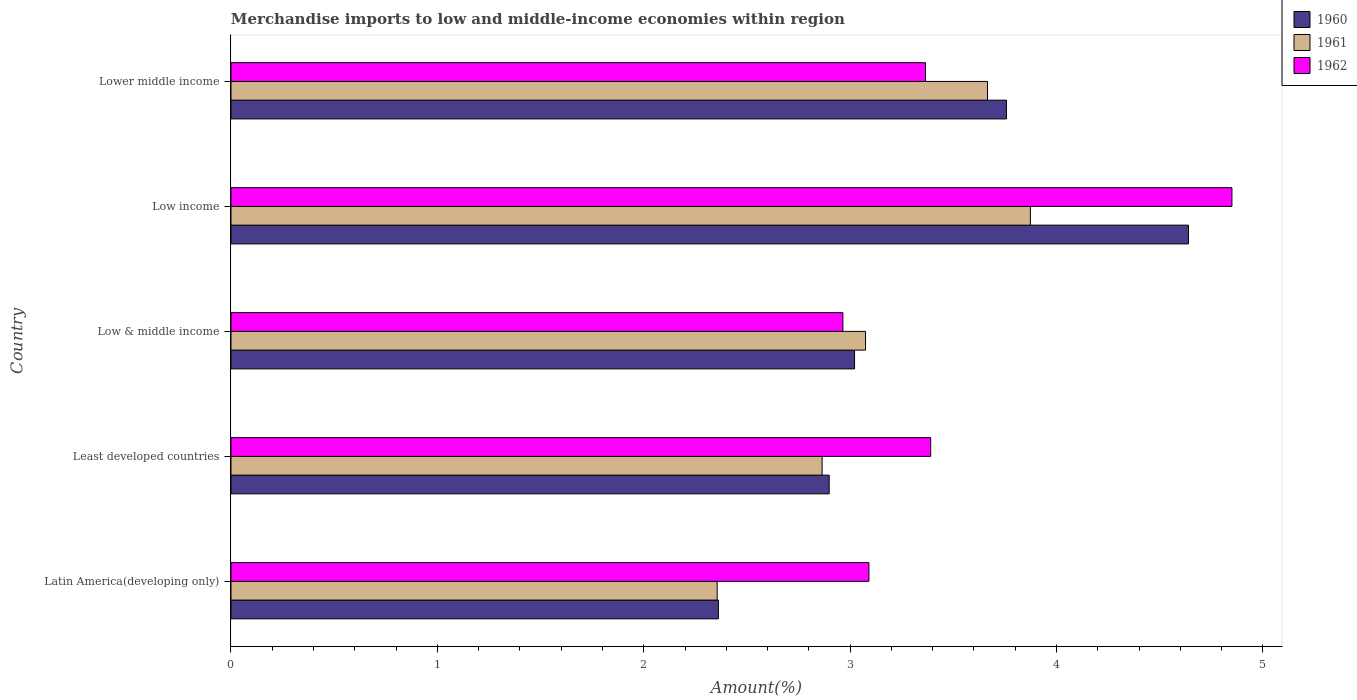How many different coloured bars are there?
Ensure brevity in your answer.  3. How many groups of bars are there?
Make the answer very short. 5. Are the number of bars on each tick of the Y-axis equal?
Give a very brief answer. Yes. How many bars are there on the 1st tick from the top?
Your response must be concise. 3. In how many cases, is the number of bars for a given country not equal to the number of legend labels?
Your response must be concise. 0. What is the percentage of amount earned from merchandise imports in 1960 in Low income?
Your answer should be very brief. 4.64. Across all countries, what is the maximum percentage of amount earned from merchandise imports in 1961?
Offer a terse response. 3.87. Across all countries, what is the minimum percentage of amount earned from merchandise imports in 1962?
Keep it short and to the point. 2.96. What is the total percentage of amount earned from merchandise imports in 1961 in the graph?
Give a very brief answer. 15.83. What is the difference between the percentage of amount earned from merchandise imports in 1961 in Latin America(developing only) and that in Low income?
Your answer should be compact. -1.52. What is the difference between the percentage of amount earned from merchandise imports in 1961 in Least developed countries and the percentage of amount earned from merchandise imports in 1960 in Low income?
Keep it short and to the point. -1.78. What is the average percentage of amount earned from merchandise imports in 1960 per country?
Offer a very short reply. 3.34. What is the difference between the percentage of amount earned from merchandise imports in 1960 and percentage of amount earned from merchandise imports in 1961 in Low income?
Your answer should be compact. 0.77. In how many countries, is the percentage of amount earned from merchandise imports in 1960 greater than 3 %?
Offer a terse response. 3. What is the ratio of the percentage of amount earned from merchandise imports in 1962 in Latin America(developing only) to that in Low income?
Offer a very short reply. 0.64. Is the percentage of amount earned from merchandise imports in 1961 in Least developed countries less than that in Low income?
Offer a very short reply. Yes. What is the difference between the highest and the second highest percentage of amount earned from merchandise imports in 1962?
Offer a very short reply. 1.46. What is the difference between the highest and the lowest percentage of amount earned from merchandise imports in 1961?
Provide a succinct answer. 1.52. In how many countries, is the percentage of amount earned from merchandise imports in 1960 greater than the average percentage of amount earned from merchandise imports in 1960 taken over all countries?
Ensure brevity in your answer.  2. What does the 3rd bar from the bottom in Lower middle income represents?
Your response must be concise. 1962. How many bars are there?
Your response must be concise. 15. Are all the bars in the graph horizontal?
Make the answer very short. Yes. How many countries are there in the graph?
Your answer should be very brief. 5. Are the values on the major ticks of X-axis written in scientific E-notation?
Your response must be concise. No. Does the graph contain any zero values?
Provide a short and direct response. No. Does the graph contain grids?
Offer a very short reply. No. Where does the legend appear in the graph?
Your answer should be very brief. Top right. How many legend labels are there?
Your answer should be very brief. 3. What is the title of the graph?
Keep it short and to the point. Merchandise imports to low and middle-income economies within region. Does "2009" appear as one of the legend labels in the graph?
Your answer should be very brief. No. What is the label or title of the X-axis?
Offer a terse response. Amount(%). What is the label or title of the Y-axis?
Ensure brevity in your answer.  Country. What is the Amount(%) in 1960 in Latin America(developing only)?
Offer a terse response. 2.36. What is the Amount(%) in 1961 in Latin America(developing only)?
Your answer should be compact. 2.36. What is the Amount(%) in 1962 in Latin America(developing only)?
Provide a succinct answer. 3.09. What is the Amount(%) of 1960 in Least developed countries?
Keep it short and to the point. 2.9. What is the Amount(%) of 1961 in Least developed countries?
Keep it short and to the point. 2.86. What is the Amount(%) in 1962 in Least developed countries?
Make the answer very short. 3.39. What is the Amount(%) of 1960 in Low & middle income?
Provide a succinct answer. 3.02. What is the Amount(%) of 1961 in Low & middle income?
Offer a terse response. 3.07. What is the Amount(%) of 1962 in Low & middle income?
Provide a succinct answer. 2.96. What is the Amount(%) of 1960 in Low income?
Provide a succinct answer. 4.64. What is the Amount(%) of 1961 in Low income?
Offer a very short reply. 3.87. What is the Amount(%) of 1962 in Low income?
Give a very brief answer. 4.85. What is the Amount(%) of 1960 in Lower middle income?
Provide a short and direct response. 3.76. What is the Amount(%) of 1961 in Lower middle income?
Make the answer very short. 3.67. What is the Amount(%) in 1962 in Lower middle income?
Keep it short and to the point. 3.37. Across all countries, what is the maximum Amount(%) in 1960?
Give a very brief answer. 4.64. Across all countries, what is the maximum Amount(%) in 1961?
Your response must be concise. 3.87. Across all countries, what is the maximum Amount(%) in 1962?
Give a very brief answer. 4.85. Across all countries, what is the minimum Amount(%) of 1960?
Make the answer very short. 2.36. Across all countries, what is the minimum Amount(%) of 1961?
Offer a very short reply. 2.36. Across all countries, what is the minimum Amount(%) of 1962?
Keep it short and to the point. 2.96. What is the total Amount(%) in 1960 in the graph?
Make the answer very short. 16.68. What is the total Amount(%) in 1961 in the graph?
Your response must be concise. 15.83. What is the total Amount(%) of 1962 in the graph?
Provide a succinct answer. 17.66. What is the difference between the Amount(%) of 1960 in Latin America(developing only) and that in Least developed countries?
Keep it short and to the point. -0.54. What is the difference between the Amount(%) of 1961 in Latin America(developing only) and that in Least developed countries?
Keep it short and to the point. -0.51. What is the difference between the Amount(%) in 1962 in Latin America(developing only) and that in Least developed countries?
Provide a succinct answer. -0.3. What is the difference between the Amount(%) of 1960 in Latin America(developing only) and that in Low & middle income?
Ensure brevity in your answer.  -0.66. What is the difference between the Amount(%) of 1961 in Latin America(developing only) and that in Low & middle income?
Your answer should be very brief. -0.72. What is the difference between the Amount(%) in 1962 in Latin America(developing only) and that in Low & middle income?
Your answer should be compact. 0.13. What is the difference between the Amount(%) in 1960 in Latin America(developing only) and that in Low income?
Your answer should be compact. -2.28. What is the difference between the Amount(%) of 1961 in Latin America(developing only) and that in Low income?
Your answer should be compact. -1.52. What is the difference between the Amount(%) of 1962 in Latin America(developing only) and that in Low income?
Provide a short and direct response. -1.76. What is the difference between the Amount(%) in 1960 in Latin America(developing only) and that in Lower middle income?
Your answer should be compact. -1.4. What is the difference between the Amount(%) of 1961 in Latin America(developing only) and that in Lower middle income?
Your answer should be compact. -1.31. What is the difference between the Amount(%) in 1962 in Latin America(developing only) and that in Lower middle income?
Offer a very short reply. -0.27. What is the difference between the Amount(%) in 1960 in Least developed countries and that in Low & middle income?
Your response must be concise. -0.12. What is the difference between the Amount(%) in 1961 in Least developed countries and that in Low & middle income?
Offer a very short reply. -0.21. What is the difference between the Amount(%) in 1962 in Least developed countries and that in Low & middle income?
Your response must be concise. 0.43. What is the difference between the Amount(%) in 1960 in Least developed countries and that in Low income?
Your response must be concise. -1.74. What is the difference between the Amount(%) of 1961 in Least developed countries and that in Low income?
Keep it short and to the point. -1.01. What is the difference between the Amount(%) in 1962 in Least developed countries and that in Low income?
Your answer should be very brief. -1.46. What is the difference between the Amount(%) in 1960 in Least developed countries and that in Lower middle income?
Your response must be concise. -0.86. What is the difference between the Amount(%) of 1961 in Least developed countries and that in Lower middle income?
Offer a very short reply. -0.8. What is the difference between the Amount(%) of 1962 in Least developed countries and that in Lower middle income?
Provide a succinct answer. 0.03. What is the difference between the Amount(%) of 1960 in Low & middle income and that in Low income?
Offer a very short reply. -1.62. What is the difference between the Amount(%) of 1961 in Low & middle income and that in Low income?
Your answer should be compact. -0.8. What is the difference between the Amount(%) in 1962 in Low & middle income and that in Low income?
Keep it short and to the point. -1.89. What is the difference between the Amount(%) in 1960 in Low & middle income and that in Lower middle income?
Your answer should be compact. -0.74. What is the difference between the Amount(%) in 1961 in Low & middle income and that in Lower middle income?
Give a very brief answer. -0.59. What is the difference between the Amount(%) of 1962 in Low & middle income and that in Lower middle income?
Keep it short and to the point. -0.4. What is the difference between the Amount(%) of 1960 in Low income and that in Lower middle income?
Make the answer very short. 0.88. What is the difference between the Amount(%) of 1961 in Low income and that in Lower middle income?
Keep it short and to the point. 0.21. What is the difference between the Amount(%) of 1962 in Low income and that in Lower middle income?
Provide a succinct answer. 1.48. What is the difference between the Amount(%) in 1960 in Latin America(developing only) and the Amount(%) in 1961 in Least developed countries?
Offer a very short reply. -0.5. What is the difference between the Amount(%) of 1960 in Latin America(developing only) and the Amount(%) of 1962 in Least developed countries?
Your answer should be compact. -1.03. What is the difference between the Amount(%) of 1961 in Latin America(developing only) and the Amount(%) of 1962 in Least developed countries?
Ensure brevity in your answer.  -1.03. What is the difference between the Amount(%) in 1960 in Latin America(developing only) and the Amount(%) in 1961 in Low & middle income?
Keep it short and to the point. -0.71. What is the difference between the Amount(%) of 1960 in Latin America(developing only) and the Amount(%) of 1962 in Low & middle income?
Give a very brief answer. -0.6. What is the difference between the Amount(%) of 1961 in Latin America(developing only) and the Amount(%) of 1962 in Low & middle income?
Ensure brevity in your answer.  -0.61. What is the difference between the Amount(%) in 1960 in Latin America(developing only) and the Amount(%) in 1961 in Low income?
Offer a very short reply. -1.51. What is the difference between the Amount(%) of 1960 in Latin America(developing only) and the Amount(%) of 1962 in Low income?
Offer a terse response. -2.49. What is the difference between the Amount(%) of 1961 in Latin America(developing only) and the Amount(%) of 1962 in Low income?
Keep it short and to the point. -2.49. What is the difference between the Amount(%) in 1960 in Latin America(developing only) and the Amount(%) in 1961 in Lower middle income?
Keep it short and to the point. -1.3. What is the difference between the Amount(%) in 1960 in Latin America(developing only) and the Amount(%) in 1962 in Lower middle income?
Provide a short and direct response. -1. What is the difference between the Amount(%) in 1961 in Latin America(developing only) and the Amount(%) in 1962 in Lower middle income?
Your answer should be compact. -1.01. What is the difference between the Amount(%) of 1960 in Least developed countries and the Amount(%) of 1961 in Low & middle income?
Ensure brevity in your answer.  -0.18. What is the difference between the Amount(%) of 1960 in Least developed countries and the Amount(%) of 1962 in Low & middle income?
Offer a terse response. -0.07. What is the difference between the Amount(%) in 1961 in Least developed countries and the Amount(%) in 1962 in Low & middle income?
Ensure brevity in your answer.  -0.1. What is the difference between the Amount(%) in 1960 in Least developed countries and the Amount(%) in 1961 in Low income?
Provide a succinct answer. -0.97. What is the difference between the Amount(%) in 1960 in Least developed countries and the Amount(%) in 1962 in Low income?
Keep it short and to the point. -1.95. What is the difference between the Amount(%) of 1961 in Least developed countries and the Amount(%) of 1962 in Low income?
Give a very brief answer. -1.99. What is the difference between the Amount(%) in 1960 in Least developed countries and the Amount(%) in 1961 in Lower middle income?
Ensure brevity in your answer.  -0.77. What is the difference between the Amount(%) of 1960 in Least developed countries and the Amount(%) of 1962 in Lower middle income?
Give a very brief answer. -0.47. What is the difference between the Amount(%) in 1961 in Least developed countries and the Amount(%) in 1962 in Lower middle income?
Make the answer very short. -0.5. What is the difference between the Amount(%) of 1960 in Low & middle income and the Amount(%) of 1961 in Low income?
Your response must be concise. -0.85. What is the difference between the Amount(%) in 1960 in Low & middle income and the Amount(%) in 1962 in Low income?
Keep it short and to the point. -1.83. What is the difference between the Amount(%) in 1961 in Low & middle income and the Amount(%) in 1962 in Low income?
Provide a succinct answer. -1.78. What is the difference between the Amount(%) in 1960 in Low & middle income and the Amount(%) in 1961 in Lower middle income?
Provide a short and direct response. -0.64. What is the difference between the Amount(%) of 1960 in Low & middle income and the Amount(%) of 1962 in Lower middle income?
Your answer should be very brief. -0.34. What is the difference between the Amount(%) of 1961 in Low & middle income and the Amount(%) of 1962 in Lower middle income?
Give a very brief answer. -0.29. What is the difference between the Amount(%) in 1960 in Low income and the Amount(%) in 1962 in Lower middle income?
Offer a terse response. 1.27. What is the difference between the Amount(%) of 1961 in Low income and the Amount(%) of 1962 in Lower middle income?
Make the answer very short. 0.51. What is the average Amount(%) of 1960 per country?
Provide a succinct answer. 3.34. What is the average Amount(%) in 1961 per country?
Your response must be concise. 3.17. What is the average Amount(%) of 1962 per country?
Provide a succinct answer. 3.53. What is the difference between the Amount(%) in 1960 and Amount(%) in 1961 in Latin America(developing only)?
Offer a terse response. 0.01. What is the difference between the Amount(%) of 1960 and Amount(%) of 1962 in Latin America(developing only)?
Keep it short and to the point. -0.73. What is the difference between the Amount(%) in 1961 and Amount(%) in 1962 in Latin America(developing only)?
Make the answer very short. -0.74. What is the difference between the Amount(%) of 1960 and Amount(%) of 1961 in Least developed countries?
Ensure brevity in your answer.  0.03. What is the difference between the Amount(%) of 1960 and Amount(%) of 1962 in Least developed countries?
Provide a succinct answer. -0.49. What is the difference between the Amount(%) in 1961 and Amount(%) in 1962 in Least developed countries?
Offer a very short reply. -0.53. What is the difference between the Amount(%) in 1960 and Amount(%) in 1961 in Low & middle income?
Your answer should be compact. -0.05. What is the difference between the Amount(%) of 1960 and Amount(%) of 1962 in Low & middle income?
Provide a short and direct response. 0.06. What is the difference between the Amount(%) in 1961 and Amount(%) in 1962 in Low & middle income?
Your answer should be very brief. 0.11. What is the difference between the Amount(%) in 1960 and Amount(%) in 1961 in Low income?
Offer a very short reply. 0.77. What is the difference between the Amount(%) in 1960 and Amount(%) in 1962 in Low income?
Provide a succinct answer. -0.21. What is the difference between the Amount(%) in 1961 and Amount(%) in 1962 in Low income?
Offer a terse response. -0.98. What is the difference between the Amount(%) of 1960 and Amount(%) of 1961 in Lower middle income?
Offer a very short reply. 0.09. What is the difference between the Amount(%) in 1960 and Amount(%) in 1962 in Lower middle income?
Your answer should be compact. 0.39. What is the difference between the Amount(%) in 1961 and Amount(%) in 1962 in Lower middle income?
Offer a terse response. 0.3. What is the ratio of the Amount(%) of 1960 in Latin America(developing only) to that in Least developed countries?
Your answer should be compact. 0.81. What is the ratio of the Amount(%) of 1961 in Latin America(developing only) to that in Least developed countries?
Your answer should be very brief. 0.82. What is the ratio of the Amount(%) in 1962 in Latin America(developing only) to that in Least developed countries?
Provide a short and direct response. 0.91. What is the ratio of the Amount(%) of 1960 in Latin America(developing only) to that in Low & middle income?
Keep it short and to the point. 0.78. What is the ratio of the Amount(%) of 1961 in Latin America(developing only) to that in Low & middle income?
Your answer should be compact. 0.77. What is the ratio of the Amount(%) of 1962 in Latin America(developing only) to that in Low & middle income?
Your response must be concise. 1.04. What is the ratio of the Amount(%) in 1960 in Latin America(developing only) to that in Low income?
Ensure brevity in your answer.  0.51. What is the ratio of the Amount(%) of 1961 in Latin America(developing only) to that in Low income?
Keep it short and to the point. 0.61. What is the ratio of the Amount(%) in 1962 in Latin America(developing only) to that in Low income?
Your answer should be compact. 0.64. What is the ratio of the Amount(%) in 1960 in Latin America(developing only) to that in Lower middle income?
Make the answer very short. 0.63. What is the ratio of the Amount(%) in 1961 in Latin America(developing only) to that in Lower middle income?
Ensure brevity in your answer.  0.64. What is the ratio of the Amount(%) of 1962 in Latin America(developing only) to that in Lower middle income?
Provide a succinct answer. 0.92. What is the ratio of the Amount(%) of 1960 in Least developed countries to that in Low & middle income?
Provide a succinct answer. 0.96. What is the ratio of the Amount(%) in 1961 in Least developed countries to that in Low & middle income?
Offer a very short reply. 0.93. What is the ratio of the Amount(%) in 1962 in Least developed countries to that in Low & middle income?
Offer a very short reply. 1.14. What is the ratio of the Amount(%) of 1960 in Least developed countries to that in Low income?
Make the answer very short. 0.62. What is the ratio of the Amount(%) of 1961 in Least developed countries to that in Low income?
Ensure brevity in your answer.  0.74. What is the ratio of the Amount(%) in 1962 in Least developed countries to that in Low income?
Make the answer very short. 0.7. What is the ratio of the Amount(%) of 1960 in Least developed countries to that in Lower middle income?
Your answer should be very brief. 0.77. What is the ratio of the Amount(%) in 1961 in Least developed countries to that in Lower middle income?
Ensure brevity in your answer.  0.78. What is the ratio of the Amount(%) of 1962 in Least developed countries to that in Lower middle income?
Make the answer very short. 1.01. What is the ratio of the Amount(%) in 1960 in Low & middle income to that in Low income?
Your answer should be very brief. 0.65. What is the ratio of the Amount(%) in 1961 in Low & middle income to that in Low income?
Your answer should be compact. 0.79. What is the ratio of the Amount(%) in 1962 in Low & middle income to that in Low income?
Offer a terse response. 0.61. What is the ratio of the Amount(%) in 1960 in Low & middle income to that in Lower middle income?
Ensure brevity in your answer.  0.8. What is the ratio of the Amount(%) of 1961 in Low & middle income to that in Lower middle income?
Your answer should be very brief. 0.84. What is the ratio of the Amount(%) of 1962 in Low & middle income to that in Lower middle income?
Offer a very short reply. 0.88. What is the ratio of the Amount(%) in 1960 in Low income to that in Lower middle income?
Offer a very short reply. 1.23. What is the ratio of the Amount(%) of 1961 in Low income to that in Lower middle income?
Offer a very short reply. 1.06. What is the ratio of the Amount(%) in 1962 in Low income to that in Lower middle income?
Your answer should be compact. 1.44. What is the difference between the highest and the second highest Amount(%) of 1960?
Offer a terse response. 0.88. What is the difference between the highest and the second highest Amount(%) in 1961?
Your response must be concise. 0.21. What is the difference between the highest and the second highest Amount(%) in 1962?
Ensure brevity in your answer.  1.46. What is the difference between the highest and the lowest Amount(%) in 1960?
Keep it short and to the point. 2.28. What is the difference between the highest and the lowest Amount(%) in 1961?
Keep it short and to the point. 1.52. What is the difference between the highest and the lowest Amount(%) in 1962?
Provide a short and direct response. 1.89. 